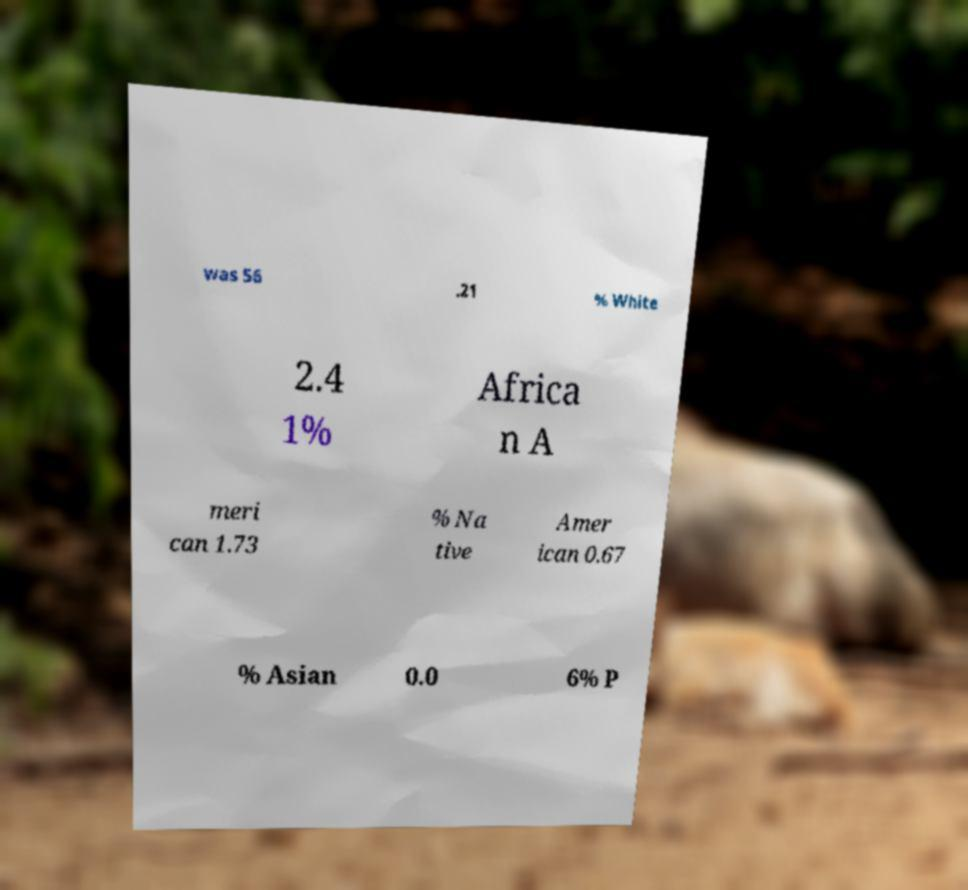There's text embedded in this image that I need extracted. Can you transcribe it verbatim? was 56 .21 % White 2.4 1% Africa n A meri can 1.73 % Na tive Amer ican 0.67 % Asian 0.0 6% P 